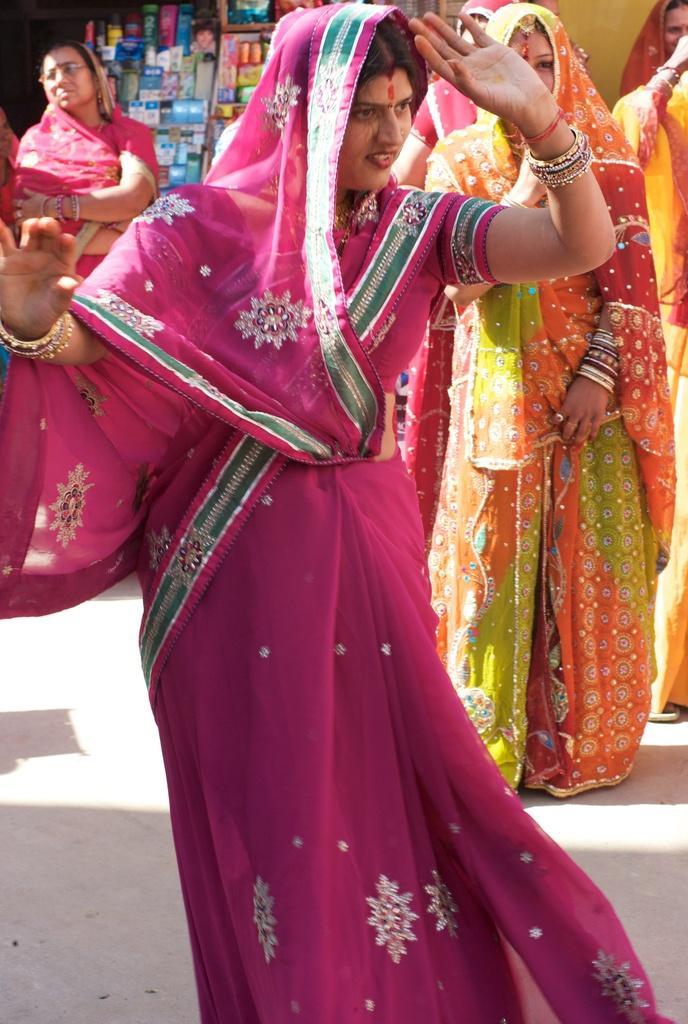How would you summarize this image in a sentence or two? As we can see in the image there are few women here and there. The woman standing in the front is wearing pink color saree and the women on the right side background is wearing yellow color sarees. In the background there is a rack filled with boxes. 